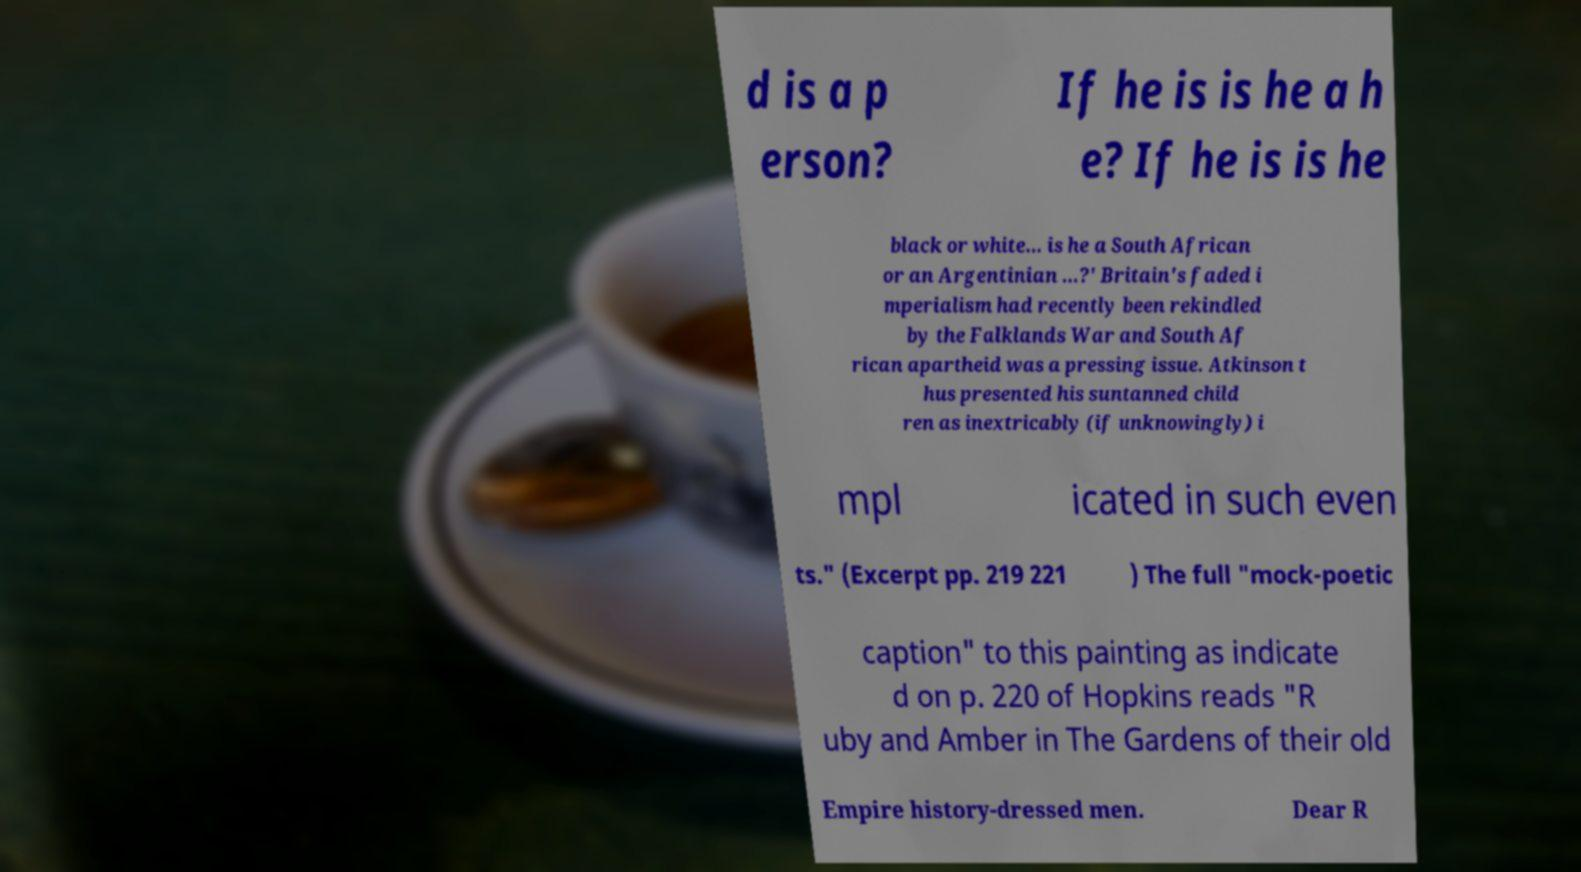Can you accurately transcribe the text from the provided image for me? d is a p erson? If he is is he a h e? If he is is he black or white… is he a South African or an Argentinian …?' Britain's faded i mperialism had recently been rekindled by the Falklands War and South Af rican apartheid was a pressing issue. Atkinson t hus presented his suntanned child ren as inextricably (if unknowingly) i mpl icated in such even ts." (Excerpt pp. 219 221 ) The full "mock-poetic caption" to this painting as indicate d on p. 220 of Hopkins reads "R uby and Amber in The Gardens of their old Empire history-dressed men. Dear R 